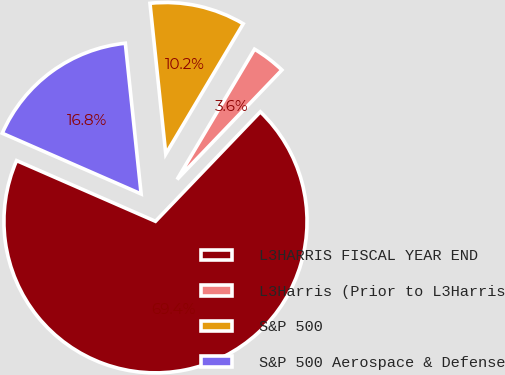Convert chart to OTSL. <chart><loc_0><loc_0><loc_500><loc_500><pie_chart><fcel>L3HARRIS FISCAL YEAR END<fcel>L3Harris (Prior to L3Harris<fcel>S&P 500<fcel>S&P 500 Aerospace & Defense<nl><fcel>69.41%<fcel>3.62%<fcel>10.2%<fcel>16.78%<nl></chart> 